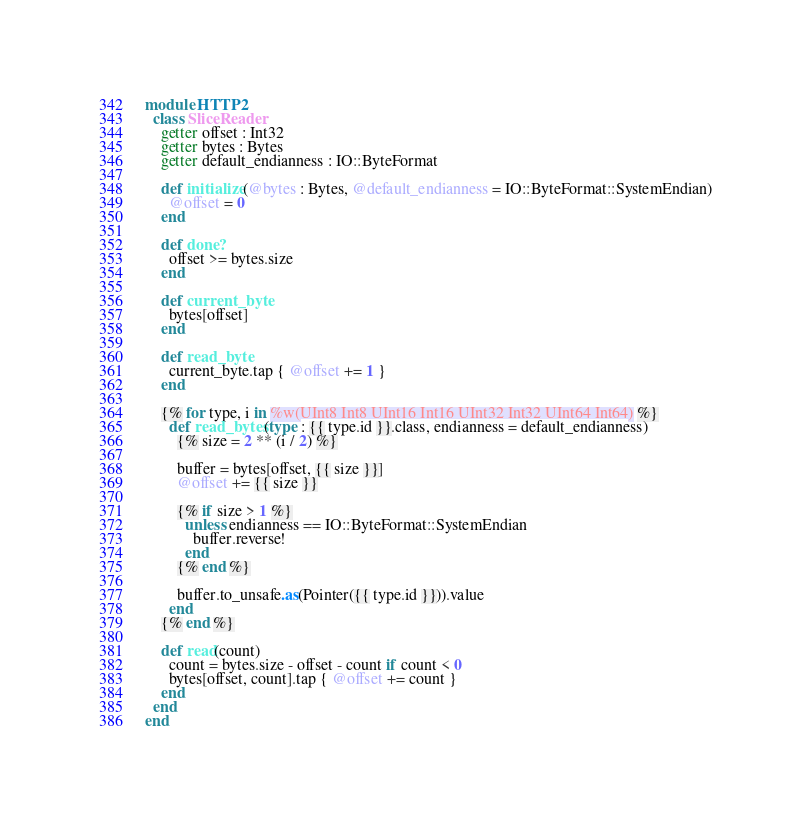<code> <loc_0><loc_0><loc_500><loc_500><_Crystal_>module HTTP2
  class SliceReader
    getter offset : Int32
    getter bytes : Bytes
    getter default_endianness : IO::ByteFormat

    def initialize(@bytes : Bytes, @default_endianness = IO::ByteFormat::SystemEndian)
      @offset = 0
    end

    def done?
      offset >= bytes.size
    end

    def current_byte
      bytes[offset]
    end

    def read_byte
      current_byte.tap { @offset += 1 }
    end

    {% for type, i in %w(UInt8 Int8 UInt16 Int16 UInt32 Int32 UInt64 Int64) %}
      def read_bytes(type : {{ type.id }}.class, endianness = default_endianness)
        {% size = 2 ** (i / 2) %}

        buffer = bytes[offset, {{ size }}]
        @offset += {{ size }}

        {% if size > 1 %}
          unless endianness == IO::ByteFormat::SystemEndian
            buffer.reverse!
          end
        {% end %}

        buffer.to_unsafe.as(Pointer({{ type.id }})).value
      end
    {% end %}

    def read(count)
      count = bytes.size - offset - count if count < 0
      bytes[offset, count].tap { @offset += count }
    end
  end
end
</code> 